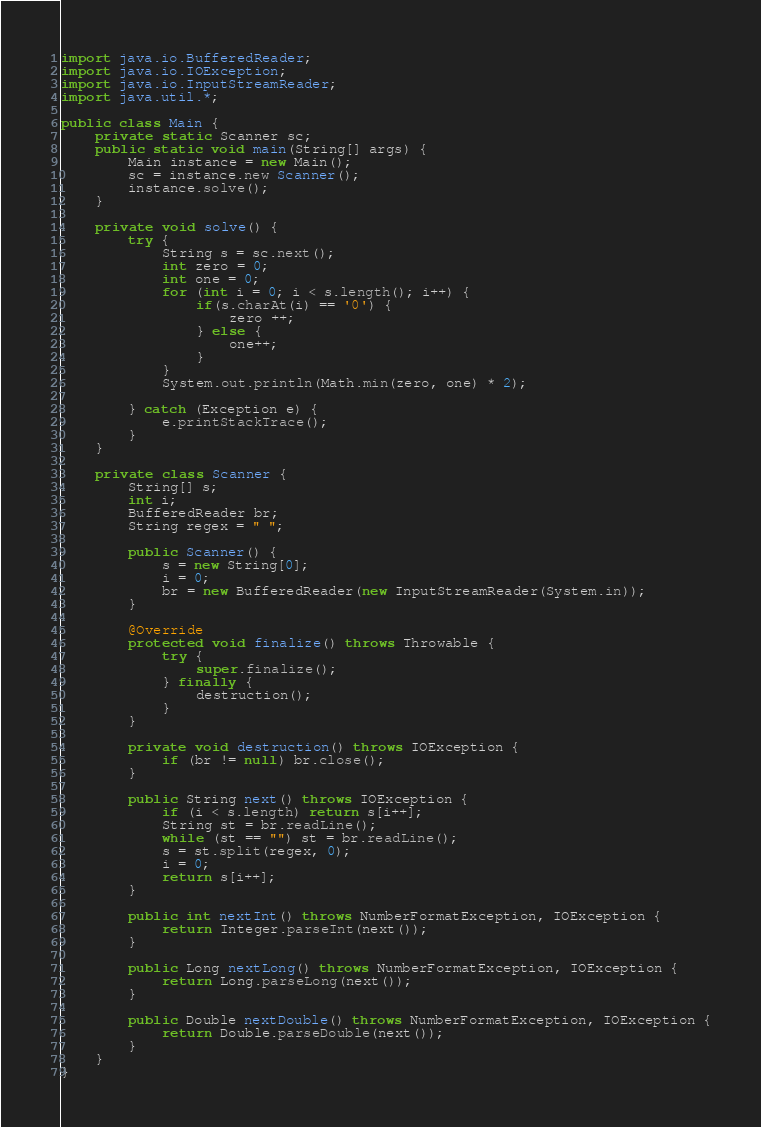<code> <loc_0><loc_0><loc_500><loc_500><_Java_>import java.io.BufferedReader;
import java.io.IOException;
import java.io.InputStreamReader;
import java.util.*;

public class Main {
    private static Scanner sc;
    public static void main(String[] args) {
        Main instance = new Main();
        sc = instance.new Scanner();
        instance.solve();
    }

    private void solve() {
        try {
            String s = sc.next();
            int zero = 0;
            int one = 0;
            for (int i = 0; i < s.length(); i++) {
                if(s.charAt(i) == '0') {
                    zero ++;
                } else {
                    one++;
                }
            }
            System.out.println(Math.min(zero, one) * 2);

        } catch (Exception e) {
            e.printStackTrace();
        }
    }

    private class Scanner {
        String[] s;
        int i;
        BufferedReader br;
        String regex = " ";

        public Scanner() {
            s = new String[0];
            i = 0;
            br = new BufferedReader(new InputStreamReader(System.in));
        }

        @Override
        protected void finalize() throws Throwable {
            try {
                super.finalize();
            } finally {
                destruction();
            }
        }

        private void destruction() throws IOException {
            if (br != null) br.close();
        }

        public String next() throws IOException {
            if (i < s.length) return s[i++];
            String st = br.readLine();
            while (st == "") st = br.readLine();
            s = st.split(regex, 0);
            i = 0;
            return s[i++];
        }

        public int nextInt() throws NumberFormatException, IOException {
            return Integer.parseInt(next());
        }

        public Long nextLong() throws NumberFormatException, IOException {
            return Long.parseLong(next());
        }

        public Double nextDouble() throws NumberFormatException, IOException {
            return Double.parseDouble(next());
        }
    }
}</code> 